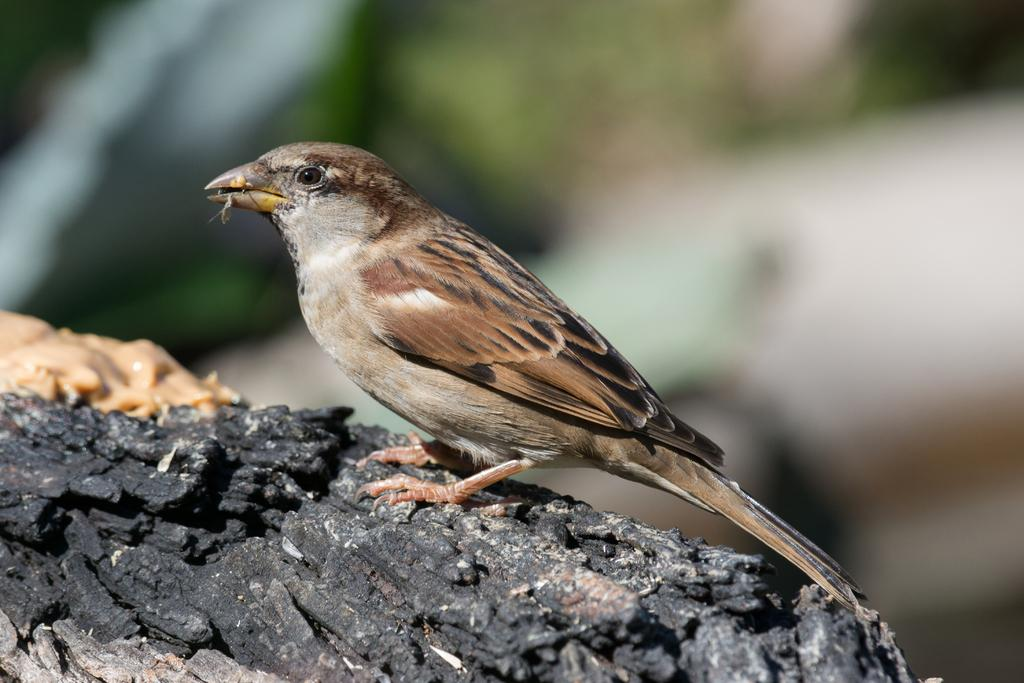What type of animal can be seen in the image? There is a bird in the image. What is the bird standing on? The bird is standing on a black object. Can you describe the background of the image? The background of the image is blurry. What is the main focus of the image? There is an object in the center of the image. What type of steel is used to construct the shop in the image? There is no shop present in the image, and therefore no steel can be observed. 